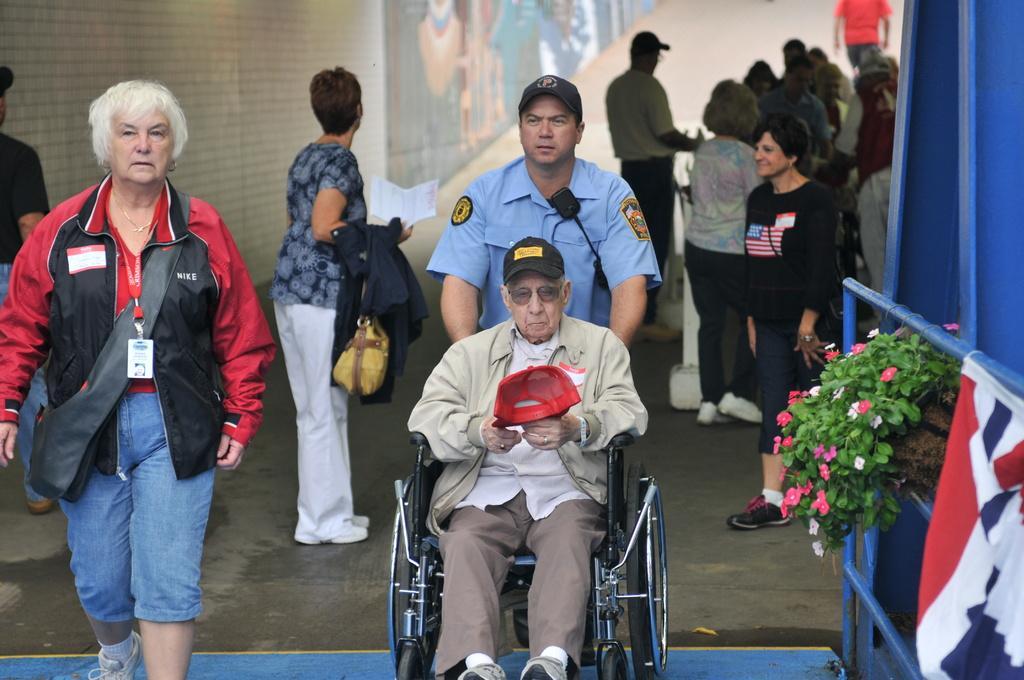Can you describe this image briefly? Here in this picture in the front we can see an old man sitting on a wheel chair and we can see a security person pushing the wheelchair and we can also see number of people are standing and walking on the ground and the woman on the left side is wearing a jacket and carrying a bag and the two persons in the middle are wearing caps and on the right side we can see a flower plant present and we can also see a flag present. 